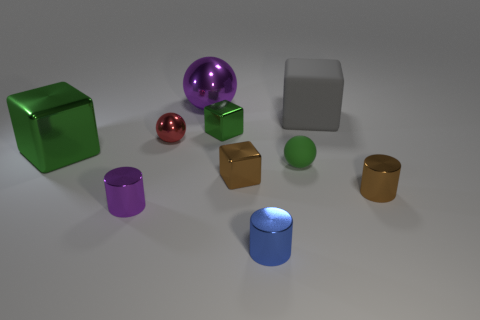There is a blue shiny object that is the same size as the purple cylinder; what is its shape?
Provide a succinct answer. Cylinder. What number of things are metallic cubes or things that are to the right of the brown metallic cube?
Your answer should be compact. 7. Does the matte cube have the same color as the big shiny block?
Provide a succinct answer. No. There is a big gray cube; what number of rubber objects are right of it?
Your answer should be very brief. 0. There is a big cube that is made of the same material as the purple ball; what is its color?
Provide a succinct answer. Green. What number of rubber objects are either tiny green things or green balls?
Your response must be concise. 1. Is the small blue object made of the same material as the tiny brown cylinder?
Offer a terse response. Yes. What is the shape of the green metal object right of the red metal sphere?
Give a very brief answer. Cube. Are there any large green cubes behind the purple shiny ball behind the large matte thing?
Ensure brevity in your answer.  No. Is there a gray rubber thing that has the same size as the blue shiny cylinder?
Your response must be concise. No. 